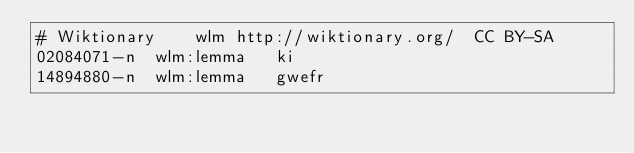<code> <loc_0><loc_0><loc_500><loc_500><_SQL_># Wiktionary	wlm	http://wiktionary.org/	CC BY-SA
02084071-n	wlm:lemma	ki
14894880-n	wlm:lemma	gwefr
</code> 